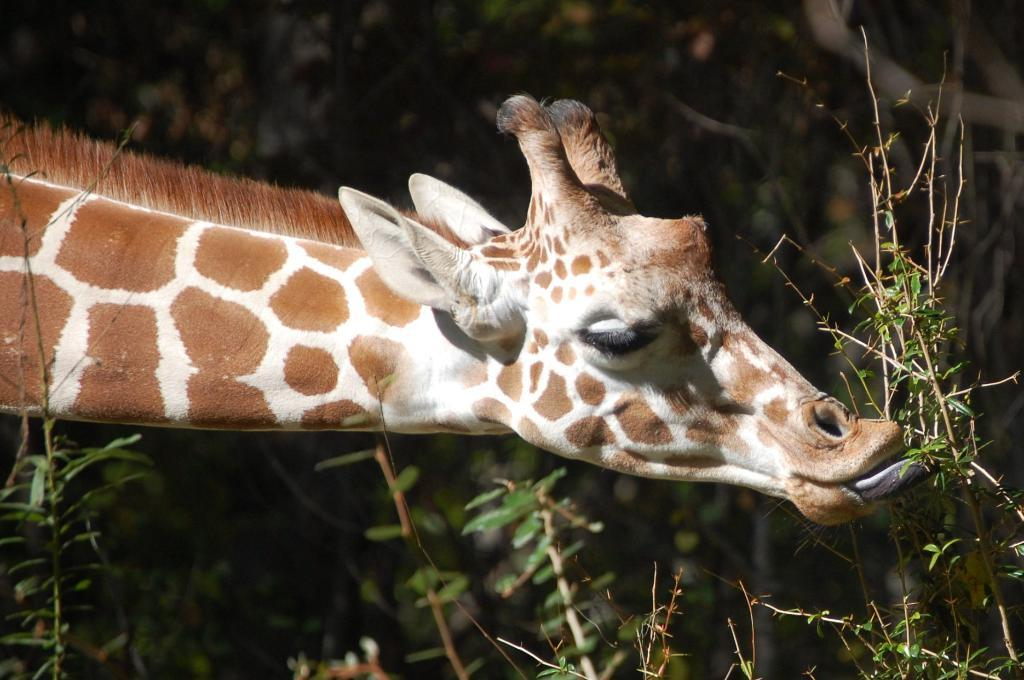What animal can be seen in the image? There is a giraffe in the image. What is the giraffe doing in the image? The giraffe is eating leaves from a plant. What can be seen in the background of the image? There are many plants and trees in the background of the image. Can you see a rod sticking out of the giraffe's back in the image? No, there is no rod visible in the image; the giraffe is simply eating leaves from a plant. 